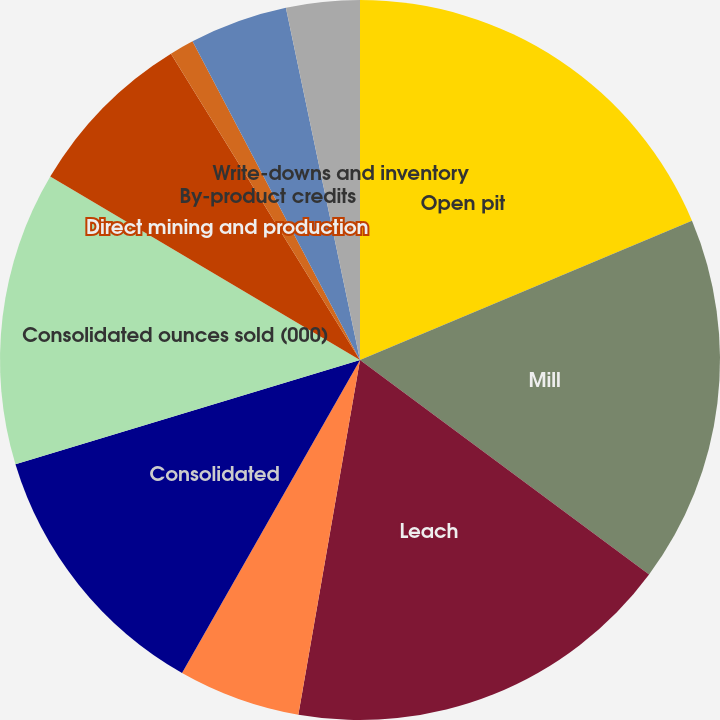Convert chart. <chart><loc_0><loc_0><loc_500><loc_500><pie_chart><fcel>Open pit<fcel>Mill<fcel>Leach<fcel>Average mill recovery rate<fcel>Consolidated<fcel>Consolidated ounces sold (000)<fcel>Direct mining and production<fcel>By-product credits<fcel>Royalties and production taxes<fcel>Write-downs and inventory<nl><fcel>18.68%<fcel>16.48%<fcel>17.58%<fcel>5.49%<fcel>12.09%<fcel>13.19%<fcel>7.69%<fcel>1.1%<fcel>4.4%<fcel>3.3%<nl></chart> 